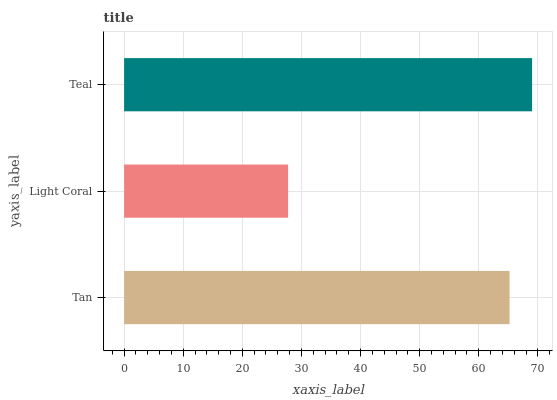Is Light Coral the minimum?
Answer yes or no. Yes. Is Teal the maximum?
Answer yes or no. Yes. Is Teal the minimum?
Answer yes or no. No. Is Light Coral the maximum?
Answer yes or no. No. Is Teal greater than Light Coral?
Answer yes or no. Yes. Is Light Coral less than Teal?
Answer yes or no. Yes. Is Light Coral greater than Teal?
Answer yes or no. No. Is Teal less than Light Coral?
Answer yes or no. No. Is Tan the high median?
Answer yes or no. Yes. Is Tan the low median?
Answer yes or no. Yes. Is Teal the high median?
Answer yes or no. No. Is Teal the low median?
Answer yes or no. No. 